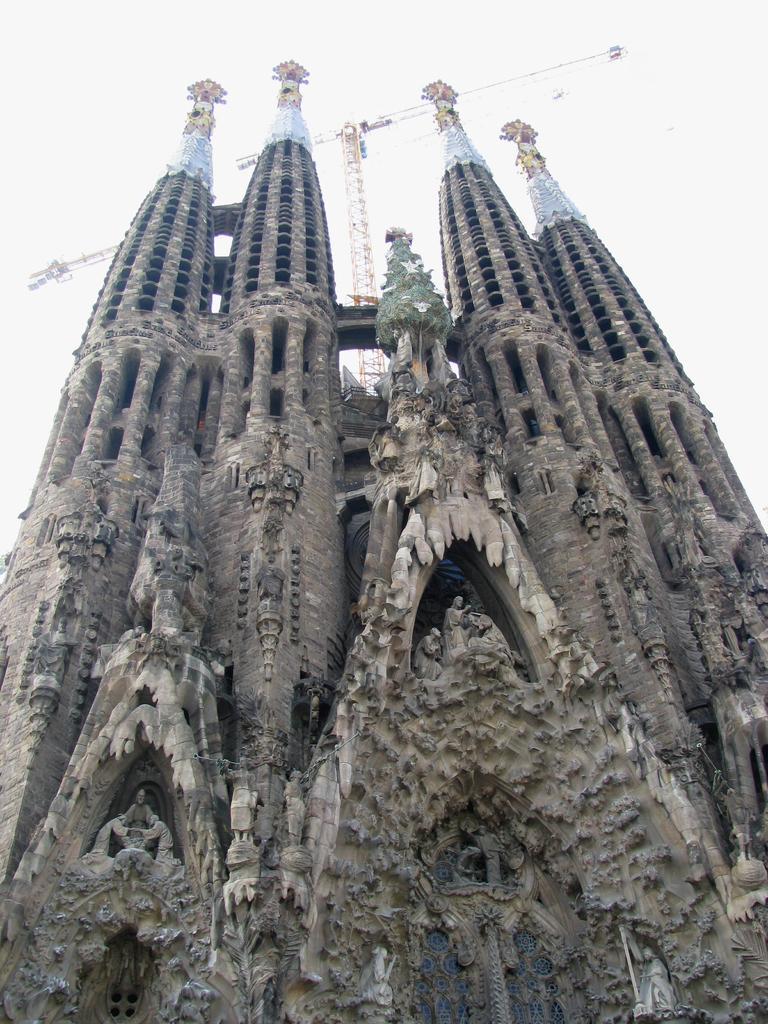Please provide a concise description of this image. In this image there is a building. Behind the building there is a crane. At the top, I can see the sky. 